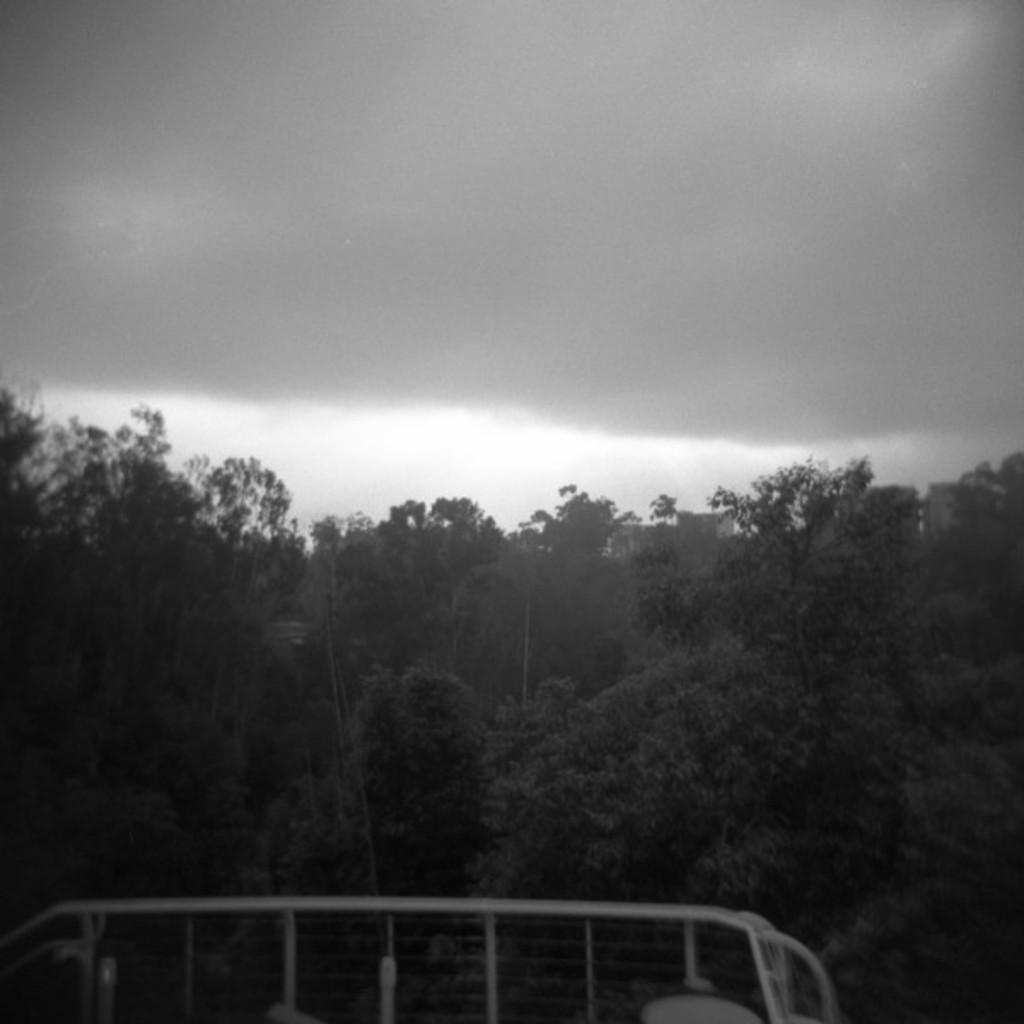What is the color scheme of the image? The image is black and white. What can be seen at the bottom of the image? There is a fence at the bottom of the image. What is visible in the background of the image? There are trees, buildings, and clouds in the sky in the background of the image. How many boots are visible in the image? There are no boots present in the image. What type of precipitation can be seen falling from the clouds in the image? There is no precipitation visible in the image; only clouds are present in the sky. 